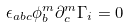Convert formula to latex. <formula><loc_0><loc_0><loc_500><loc_500>\epsilon _ { a b c } \phi ^ { m } _ { b } \partial ^ { m } _ { c } \Gamma _ { i } = 0</formula> 